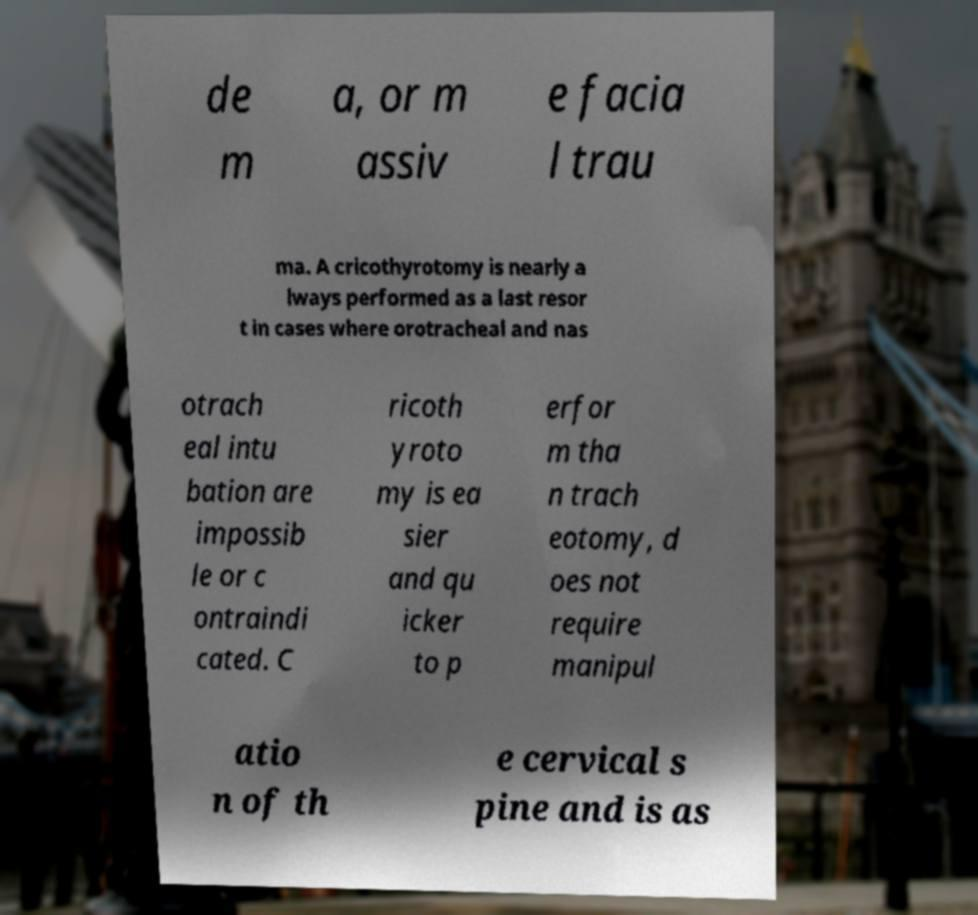I need the written content from this picture converted into text. Can you do that? de m a, or m assiv e facia l trau ma. A cricothyrotomy is nearly a lways performed as a last resor t in cases where orotracheal and nas otrach eal intu bation are impossib le or c ontraindi cated. C ricoth yroto my is ea sier and qu icker to p erfor m tha n trach eotomy, d oes not require manipul atio n of th e cervical s pine and is as 